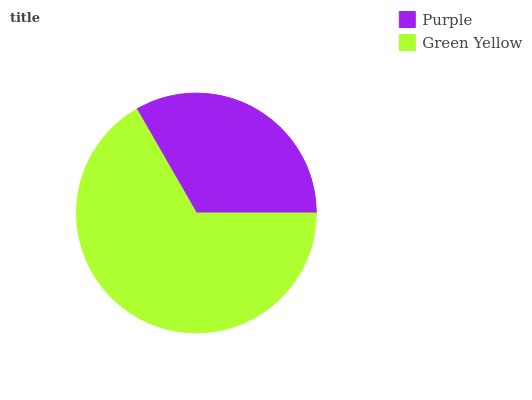Is Purple the minimum?
Answer yes or no. Yes. Is Green Yellow the maximum?
Answer yes or no. Yes. Is Green Yellow the minimum?
Answer yes or no. No. Is Green Yellow greater than Purple?
Answer yes or no. Yes. Is Purple less than Green Yellow?
Answer yes or no. Yes. Is Purple greater than Green Yellow?
Answer yes or no. No. Is Green Yellow less than Purple?
Answer yes or no. No. Is Green Yellow the high median?
Answer yes or no. Yes. Is Purple the low median?
Answer yes or no. Yes. Is Purple the high median?
Answer yes or no. No. Is Green Yellow the low median?
Answer yes or no. No. 